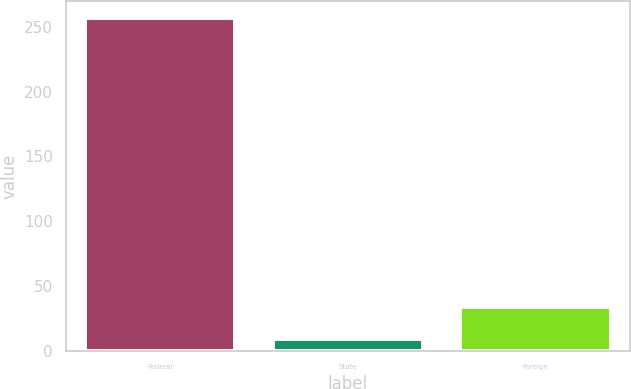<chart> <loc_0><loc_0><loc_500><loc_500><bar_chart><fcel>Federal<fcel>State<fcel>Foreign<nl><fcel>256.9<fcel>8.8<fcel>33.61<nl></chart> 